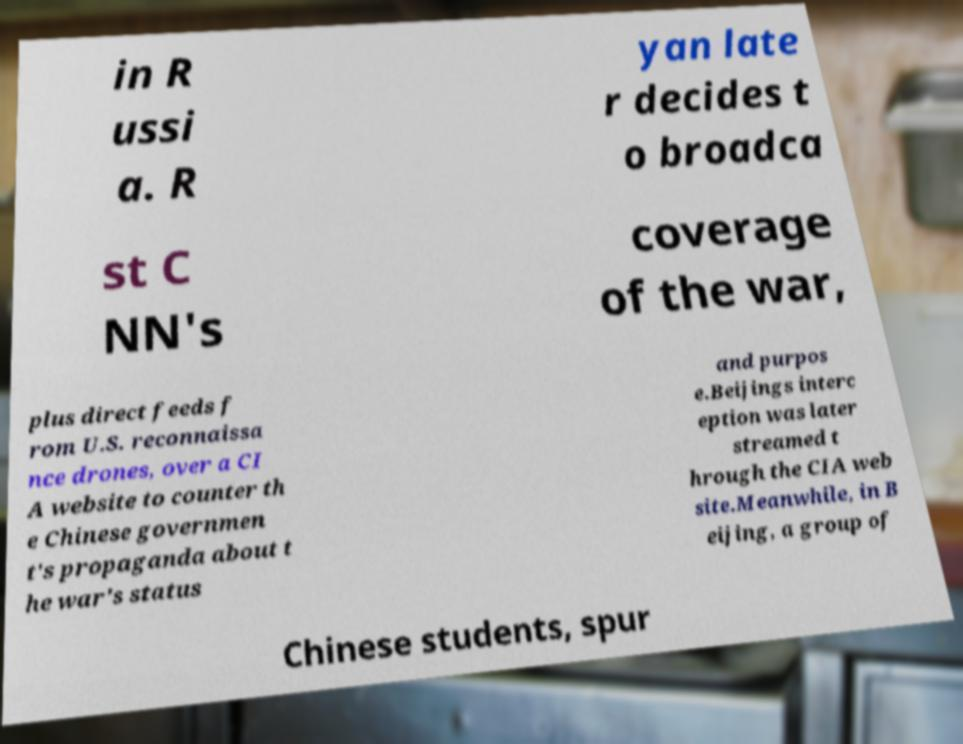I need the written content from this picture converted into text. Can you do that? in R ussi a. R yan late r decides t o broadca st C NN's coverage of the war, plus direct feeds f rom U.S. reconnaissa nce drones, over a CI A website to counter th e Chinese governmen t's propaganda about t he war's status and purpos e.Beijings interc eption was later streamed t hrough the CIA web site.Meanwhile, in B eijing, a group of Chinese students, spur 